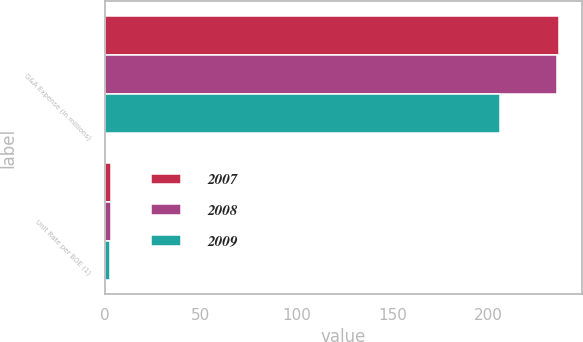<chart> <loc_0><loc_0><loc_500><loc_500><stacked_bar_chart><ecel><fcel>G&A Expense (in millions)<fcel>Unit Rate per BOE (1)<nl><fcel>2007<fcel>237<fcel>3.22<nl><fcel>2008<fcel>236<fcel>3.12<nl><fcel>2009<fcel>206<fcel>2.96<nl></chart> 